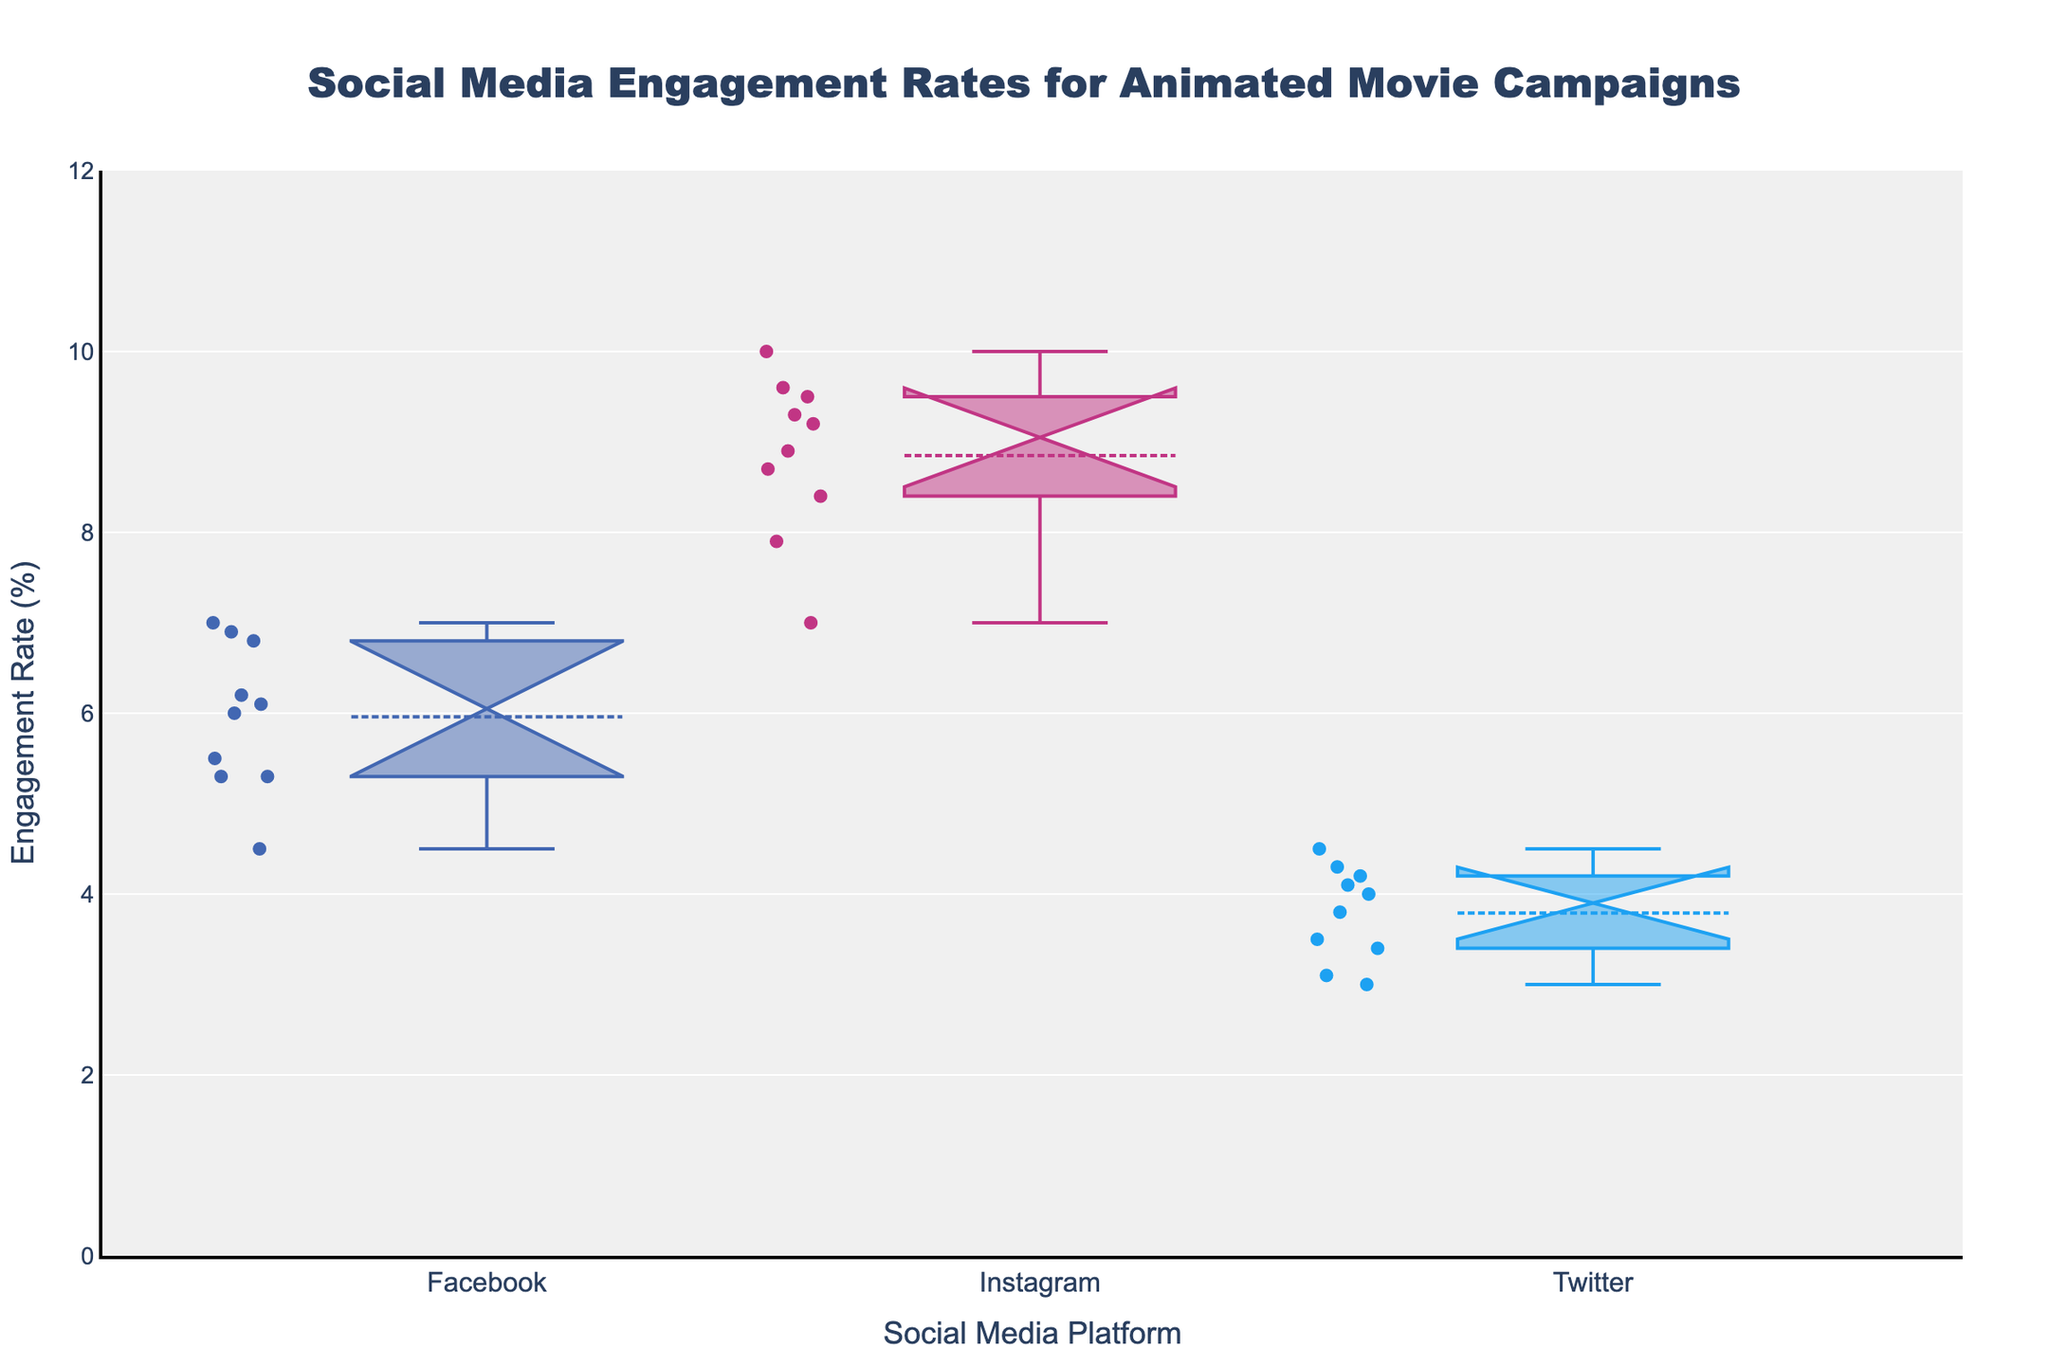What is the title of the plot? The title is typically displayed at the top of the plot. By examining the main heading, we can identify it.
Answer: Social Media Engagement Rates for Animated Movie Campaigns What are the three social media platforms shown in the plot? The x-axis of the plot displays the names of three different social media platforms, representing the categories used for the box plots.
Answer: Facebook, Instagram, Twitter Which social media platform shows the highest median engagement rate in the plot? To find this, we look at the horizontal line within the boxes which represents the median. Comparing these lines across Facebook, Instagram, and Twitter, the one with the highest median line is what we are looking for.
Answer: Instagram What is the range of the y-axis? The y-axis of the plot displays the engagement rates, and typically contains numerical values from the lowest to highest engagement rate measurement. By observing the axis, we can identify the range.
Answer: 0 to 12 Which social media platform has the widest interquartile range (IQR) of engagement rates? The IQR is represented by the height of the box (from Q1 to Q3). To find the platform with the widest IQR, compare the heights of the boxes across Facebook, Instagram, and Twitter.
Answer: Instagram How does the median engagement rate on Facebook compare to that on Twitter? To answer this, look at the horizontal lines within the boxes representing the medians for Facebook and Twitter, and compare their positions along the y-axis.
Answer: The median engagement rate on Facebook is higher than on Twitter What is the typical engagement range for Instagram based on the plot? The typical range is represented by the box itself which shows the first quartile (lower edge of the box) to the third quartile (upper edge of the box).
Answer: Approximately 8.0 to 9.8% Which platform has the most number of outliers and how can you identify them? Outliers are typically represented by points outside the 'whiskers' of the box plot. Count the number of outlier points for each platform.
Answer: Twitter, identifiable by the most points outside its whiskers What is the maximum engagement rate shown for any platform in the plot? The maximum rate can be identified as the highest data point (tip of the highest 'whisker') within the plot.
Answer: 10.0% How does the notch width in the box plot help interpret statistical significance? The notch width indicates the confidence interval around the median. If notches of two boxes do not overlap, it suggests a difference in medians at a particular confidence level; the wider the notch, the uncertain the median estimate is due to variability.
Answer: Notches help to compare medians for statistical significance 